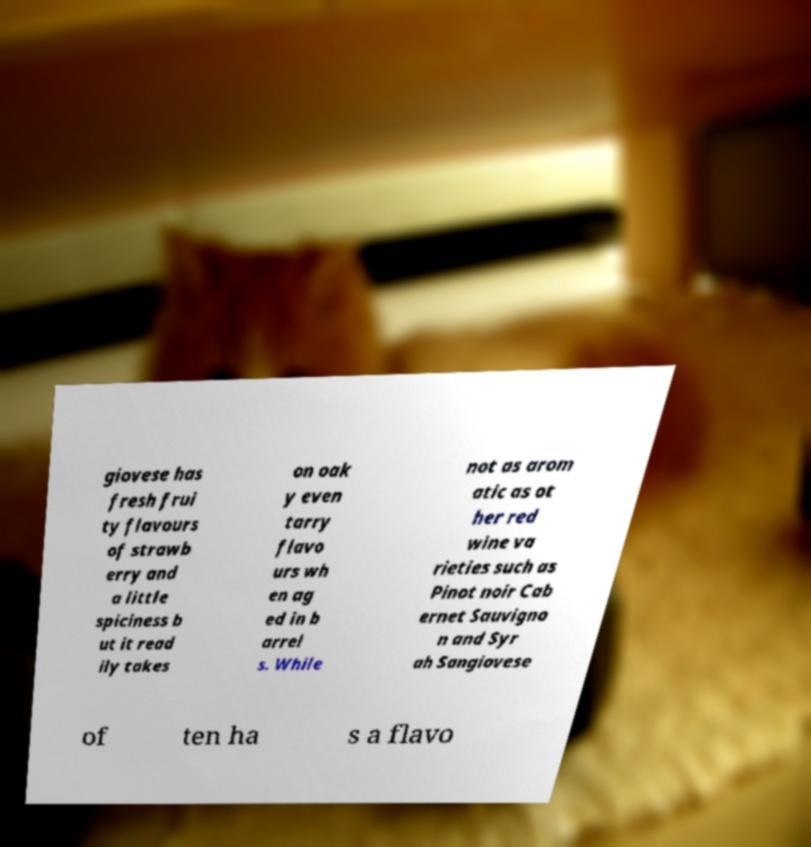I need the written content from this picture converted into text. Can you do that? giovese has fresh frui ty flavours of strawb erry and a little spiciness b ut it read ily takes on oak y even tarry flavo urs wh en ag ed in b arrel s. While not as arom atic as ot her red wine va rieties such as Pinot noir Cab ernet Sauvigno n and Syr ah Sangiovese of ten ha s a flavo 